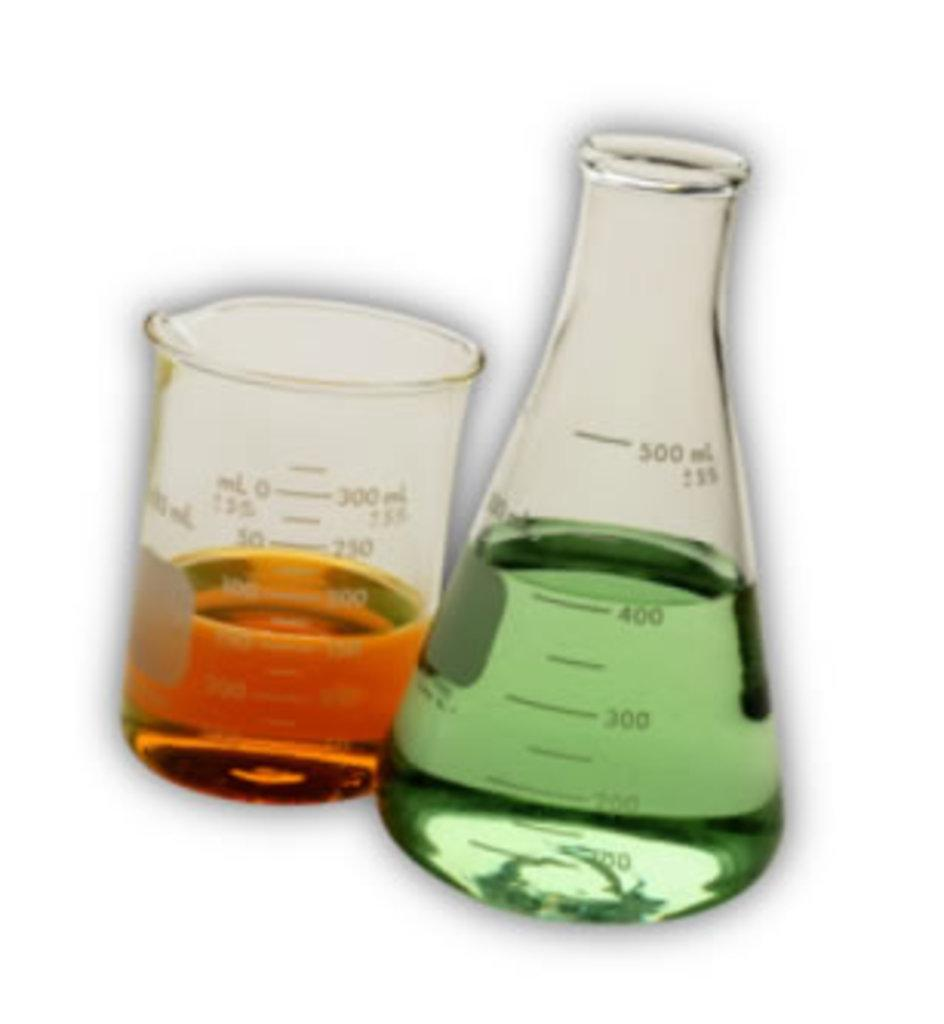<image>
Relay a brief, clear account of the picture shown. Glass containers and one has 400 ml of green liquid inside 